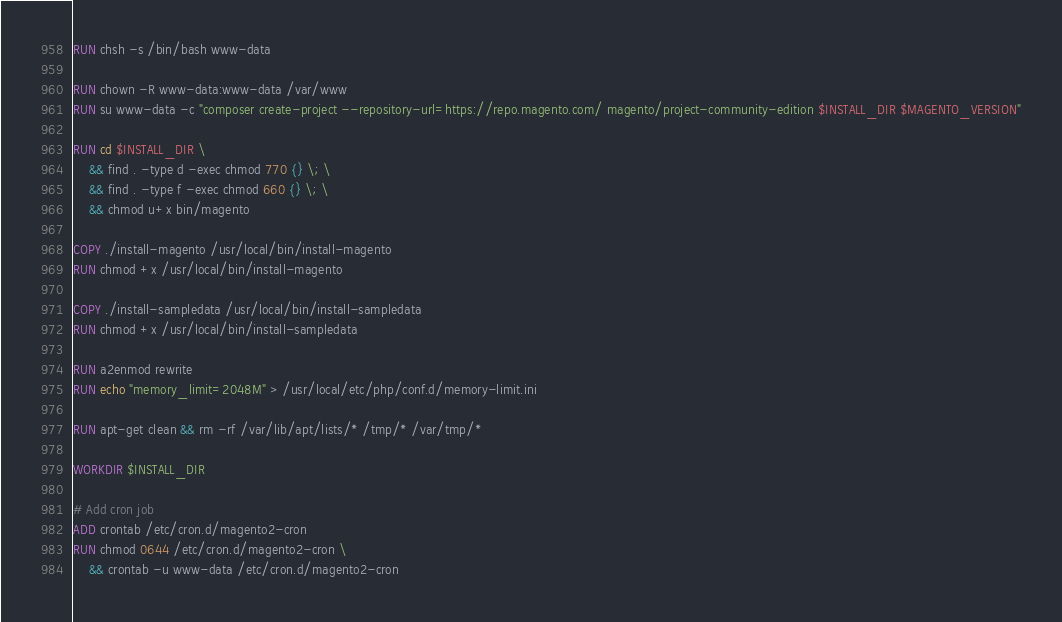<code> <loc_0><loc_0><loc_500><loc_500><_Dockerfile_>RUN chsh -s /bin/bash www-data

RUN chown -R www-data:www-data /var/www
RUN su www-data -c "composer create-project --repository-url=https://repo.magento.com/ magento/project-community-edition $INSTALL_DIR $MAGENTO_VERSION"

RUN cd $INSTALL_DIR \
    && find . -type d -exec chmod 770 {} \; \
    && find . -type f -exec chmod 660 {} \; \
    && chmod u+x bin/magento

COPY ./install-magento /usr/local/bin/install-magento
RUN chmod +x /usr/local/bin/install-magento

COPY ./install-sampledata /usr/local/bin/install-sampledata
RUN chmod +x /usr/local/bin/install-sampledata

RUN a2enmod rewrite
RUN echo "memory_limit=2048M" > /usr/local/etc/php/conf.d/memory-limit.ini

RUN apt-get clean && rm -rf /var/lib/apt/lists/* /tmp/* /var/tmp/*

WORKDIR $INSTALL_DIR

# Add cron job
ADD crontab /etc/cron.d/magento2-cron
RUN chmod 0644 /etc/cron.d/magento2-cron \
    && crontab -u www-data /etc/cron.d/magento2-cron</code> 